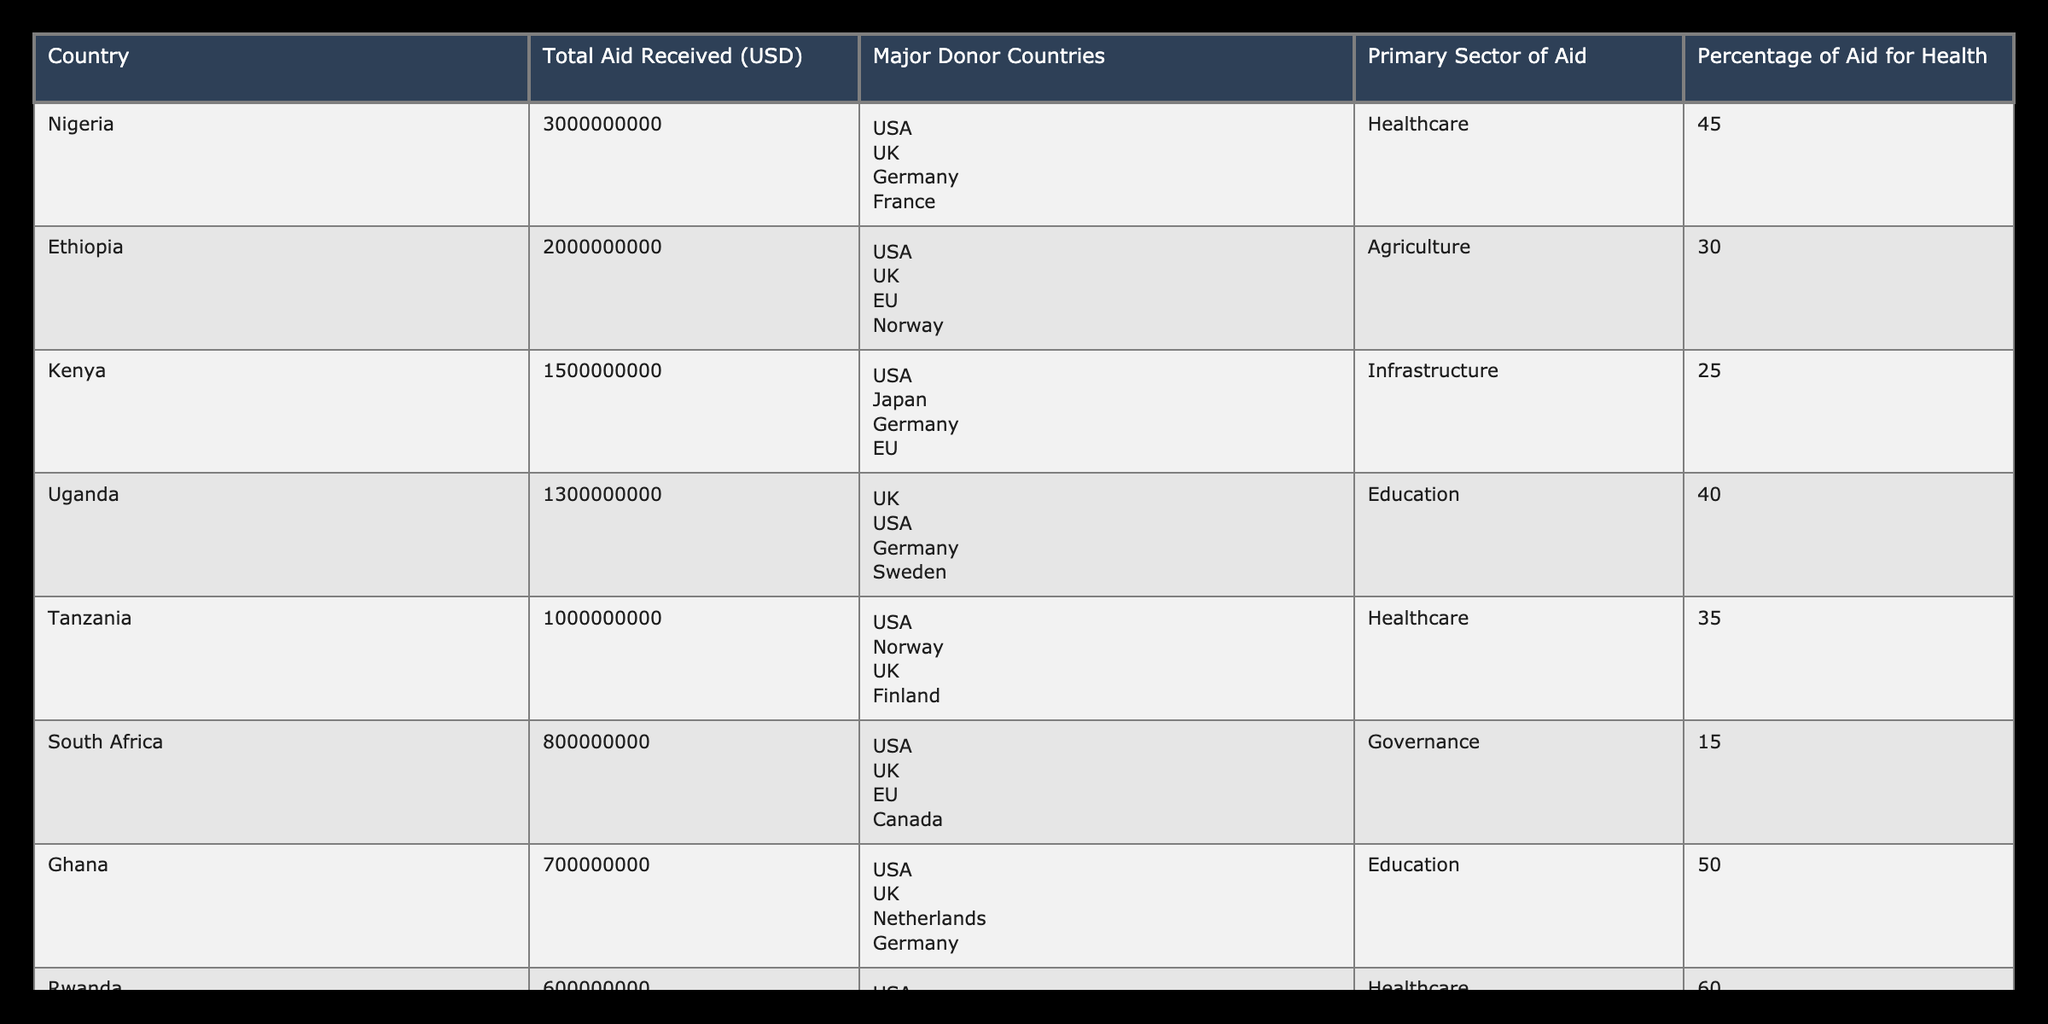What is the total aid received by Nigeria? The value for Nigeria under the "Total Aid Received (USD)" column is directly stated in the table as 3000000000 USD.
Answer: 3000000000 Which country received the least amount of aid? By comparing the values in the "Total Aid Received (USD)" column, Zambia has the lowest figure at 500000000 USD.
Answer: Zambia What percentage of aid for healthcare is received by Rwanda? The table shows that Rwanda received 60% of its aid for healthcare, which can be directly extracted from the "Percentage of Aid for Health" column.
Answer: 60% What is the average percentage of aid for health across the listed countries? Adding the percentages for health across all countries: 45 + 30 + 25 + 40 + 35 + 15 + 50 + 60 + 20 + 55 =  435. There are 10 countries, so the average is 435 / 10 = 43.5.
Answer: 43.5 Is the major donor for Uganda also a major donor for Tanzania? The major donors for Uganda are UK, USA, Germany, and Sweden, while for Tanzania they are USA, Norway, UK, and Finland. Both countries share two major donors: USA and UK, making the statement true.
Answer: Yes Which sector of aid did Nigeria receive the most funding for? The primary sector of aid for Nigeria is healthcare, as clearly stated in the table.
Answer: Healthcare How much more aid did Nigeria receive compared to Zambia? Nigeria received 3000000000 USD and Zambia received 500000000 USD. The difference is calculated as 3000000000 - 500000000 = 2500000000 USD.
Answer: 2500000000 Did Sudan receive more aid than Kenya? The aid for Sudan is 400000000 USD while Kenya received 1500000000 USD. Since 400000000 is less than 1500000000, the statement is false.
Answer: No What is the combined total aid received by the top three countries in terms of aid received? The three countries with the highest aid amounts are Nigeria (3000000000), Ethiopia (2000000000), and Kenya (1500000000). The combined total is calculated as 3000000000 + 2000000000 + 1500000000 = 6500000000 USD.
Answer: 6500000000 